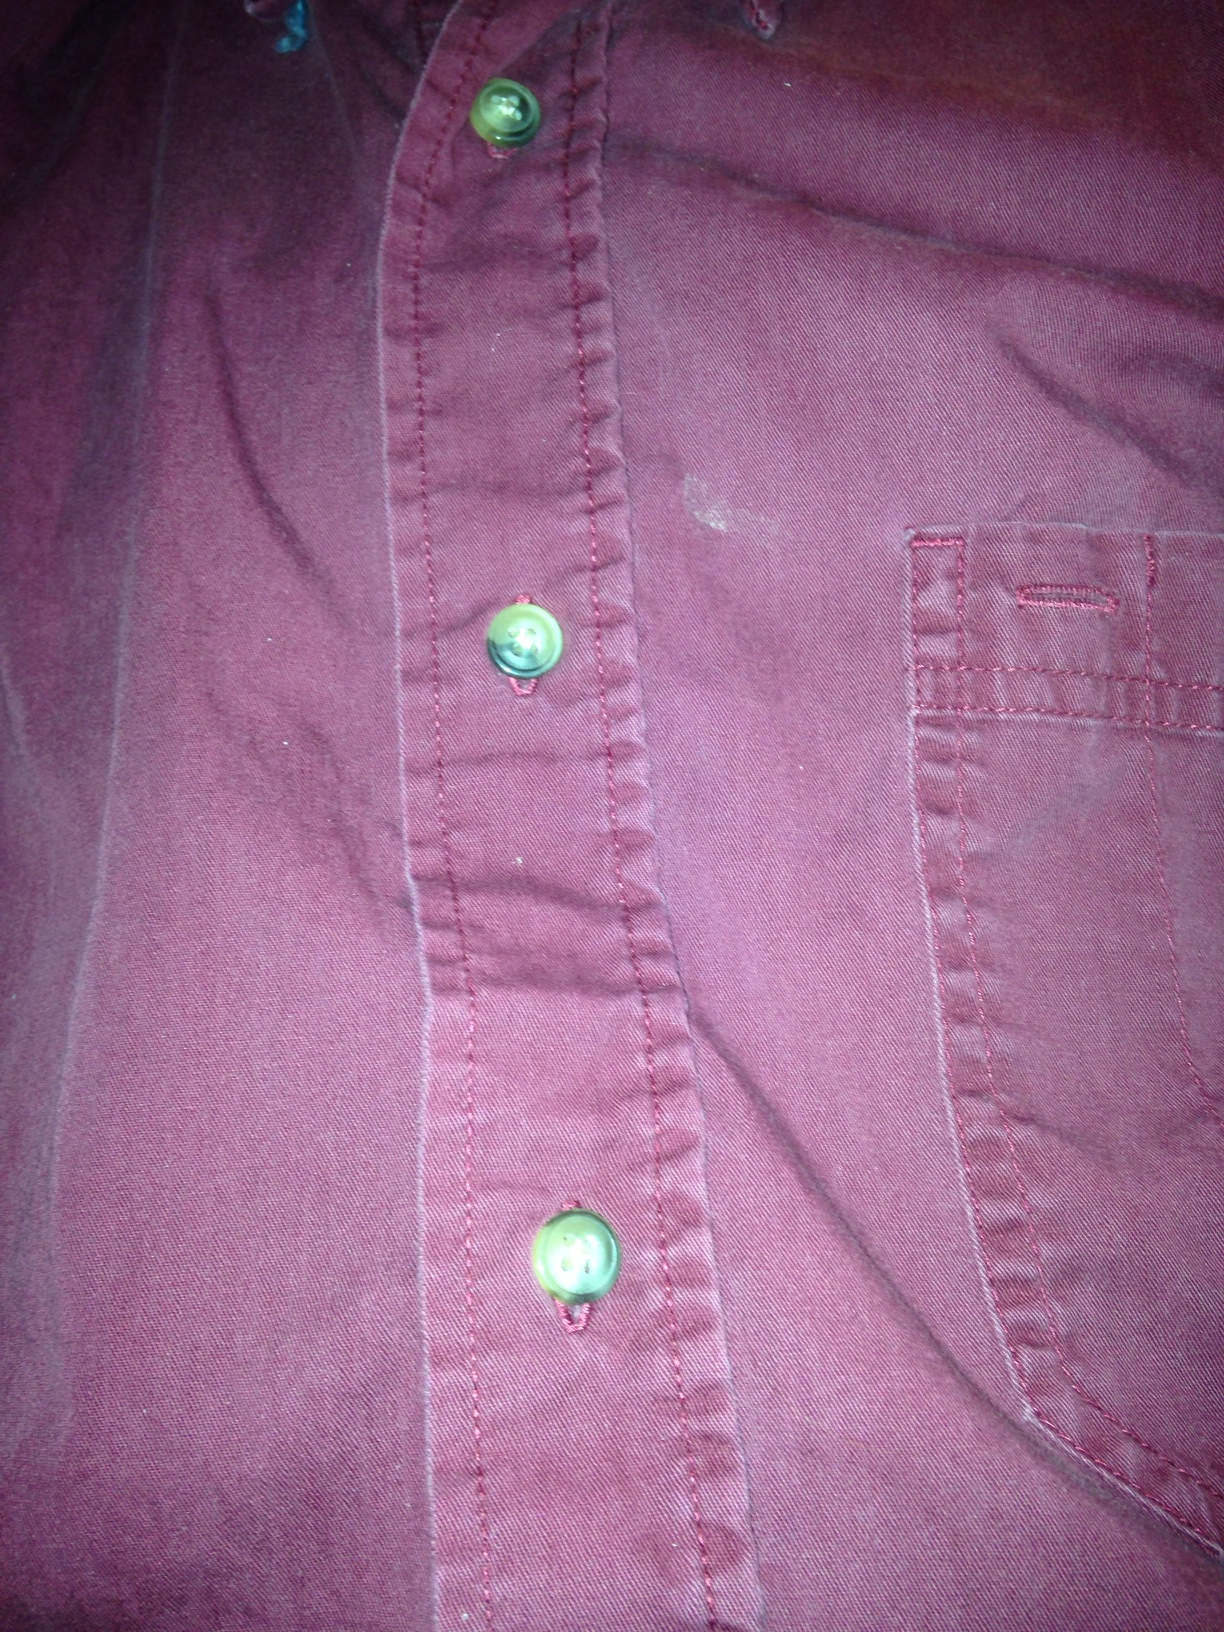How would you describe the style of this shirt based on the button design and stitching? The shirt has a classic design with prominent stitching and round, greenish buttons that stand out against the fabric. The stitching is uniform, suggesting good craftsmanship. The style leans towards casual wear, suitable for everyday activities. 